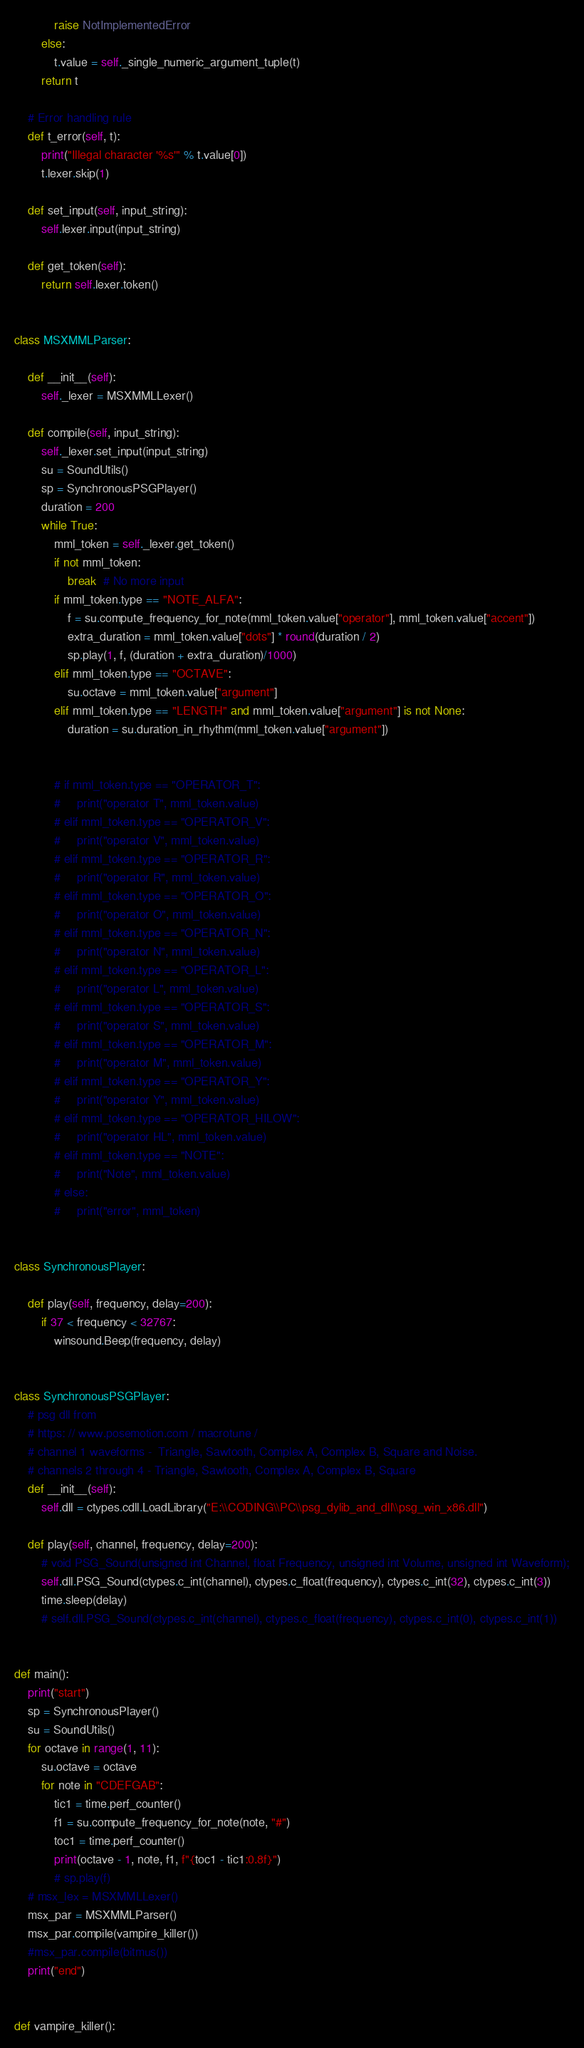<code> <loc_0><loc_0><loc_500><loc_500><_Python_>            raise NotImplementedError
        else:
            t.value = self._single_numeric_argument_tuple(t)
        return t

    # Error handling rule
    def t_error(self, t):
        print("Illegal character '%s'" % t.value[0])
        t.lexer.skip(1)

    def set_input(self, input_string):
        self.lexer.input(input_string)

    def get_token(self):
        return self.lexer.token()


class MSXMMLParser:

    def __init__(self):
        self._lexer = MSXMMLLexer()

    def compile(self, input_string):
        self._lexer.set_input(input_string)
        su = SoundUtils()
        sp = SynchronousPSGPlayer()
        duration = 200
        while True:
            mml_token = self._lexer.get_token()
            if not mml_token:
                break  # No more input
            if mml_token.type == "NOTE_ALFA":
                f = su.compute_frequency_for_note(mml_token.value["operator"], mml_token.value["accent"])
                extra_duration = mml_token.value["dots"] * round(duration / 2)
                sp.play(1, f, (duration + extra_duration)/1000)
            elif mml_token.type == "OCTAVE":
                su.octave = mml_token.value["argument"]
            elif mml_token.type == "LENGTH" and mml_token.value["argument"] is not None:
                duration = su.duration_in_rhythm(mml_token.value["argument"])


            # if mml_token.type == "OPERATOR_T":
            #     print("operator T", mml_token.value)
            # elif mml_token.type == "OPERATOR_V":
            #     print("operator V", mml_token.value)
            # elif mml_token.type == "OPERATOR_R":
            #     print("operator R", mml_token.value)
            # elif mml_token.type == "OPERATOR_O":
            #     print("operator O", mml_token.value)
            # elif mml_token.type == "OPERATOR_N":
            #     print("operator N", mml_token.value)
            # elif mml_token.type == "OPERATOR_L":
            #     print("operator L", mml_token.value)
            # elif mml_token.type == "OPERATOR_S":
            #     print("operator S", mml_token.value)
            # elif mml_token.type == "OPERATOR_M":
            #     print("operator M", mml_token.value)
            # elif mml_token.type == "OPERATOR_Y":
            #     print("operator Y", mml_token.value)
            # elif mml_token.type == "OPERATOR_HILOW":
            #     print("operator HL", mml_token.value)
            # elif mml_token.type == "NOTE":
            #     print("Note", mml_token.value)
            # else:
            #     print("error", mml_token)


class SynchronousPlayer:

    def play(self, frequency, delay=200):
        if 37 < frequency < 32767:
            winsound.Beep(frequency, delay)


class SynchronousPSGPlayer:
    # psg dll from
    # https: // www.posemotion.com / macrotune /
    # channel 1 waveforms -  Triangle, Sawtooth, Complex A, Complex B, Square and Noise.
    # channels 2 through 4 - Triangle, Sawtooth, Complex A, Complex B, Square
    def __init__(self):
        self.dll = ctypes.cdll.LoadLibrary("E:\\CODING\\PC\\psg_dylib_and_dll\\psg_win_x86.dll")

    def play(self, channel, frequency, delay=200):
        # void PSG_Sound(unsigned int Channel, float Frequency, unsigned int Volume, unsigned int Waveform);
        self.dll.PSG_Sound(ctypes.c_int(channel), ctypes.c_float(frequency), ctypes.c_int(32), ctypes.c_int(3))
        time.sleep(delay)
        # self.dll.PSG_Sound(ctypes.c_int(channel), ctypes.c_float(frequency), ctypes.c_int(0), ctypes.c_int(1))


def main():
    print("start")
    sp = SynchronousPlayer()
    su = SoundUtils()
    for octave in range(1, 11):
        su.octave = octave
        for note in "CDEFGAB":
            tic1 = time.perf_counter()
            f1 = su.compute_frequency_for_note(note, "#")
            toc1 = time.perf_counter()
            print(octave - 1, note, f1, f"{toc1 - tic1:0.8f}")
            # sp.play(f)
    # msx_lex = MSXMMLLexer()
    msx_par = MSXMMLParser()
    msx_par.compile(vampire_killer())
    #msx_par.compile(bitmus())
    print("end")


def vampire_killer():</code> 